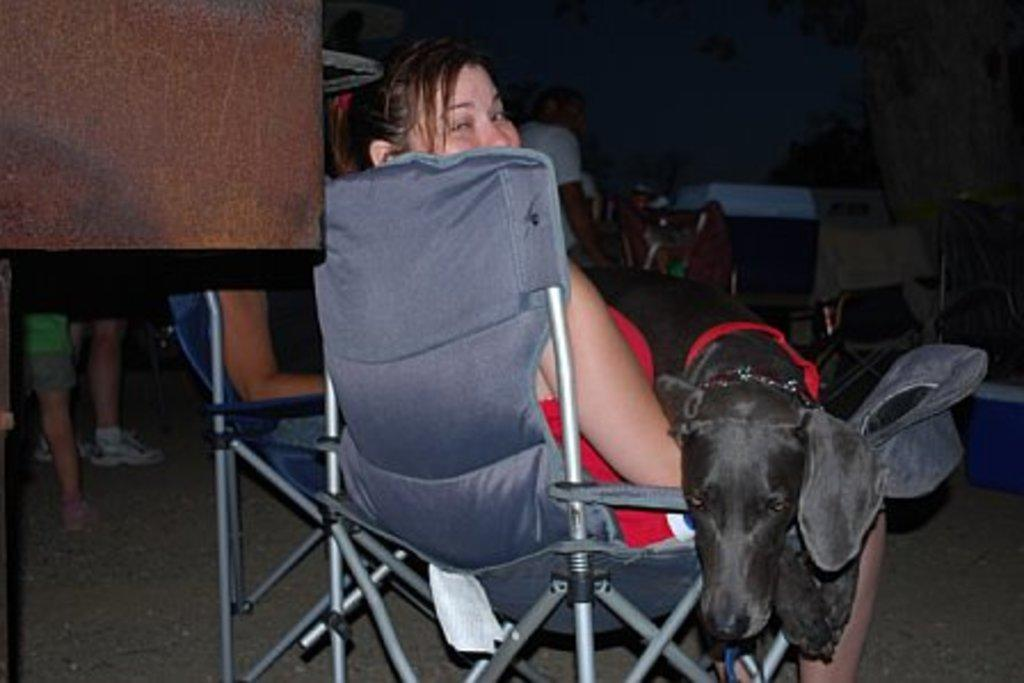What is the woman in the image doing? The woman is sitting in a chair. What is the woman holding in the image? The woman is holding a black dog. Are there any other people present in the image? Yes, there are other people beside the woman. What type of chalk is the woman using to draw on the dog in the image? There is no chalk present in the image, and the woman is not drawing on the dog. 